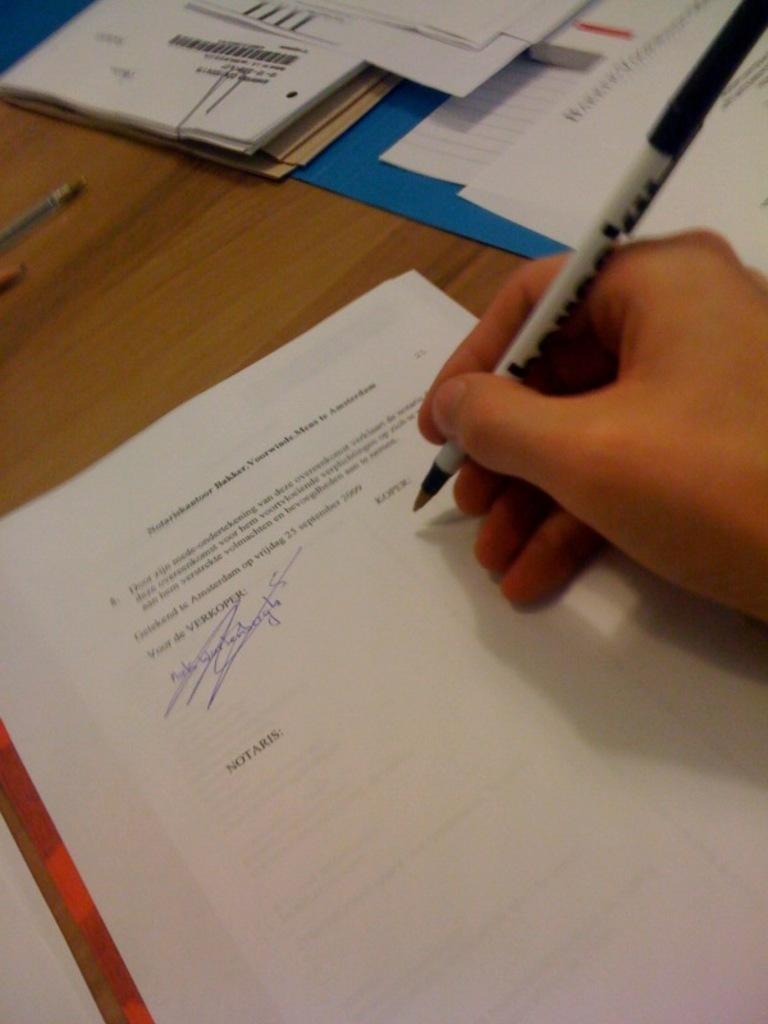Describe this image in one or two sentences. In he picture we can see a person's hand holding a pen. Here we can see papers, files and a few more things on the wooden table. 